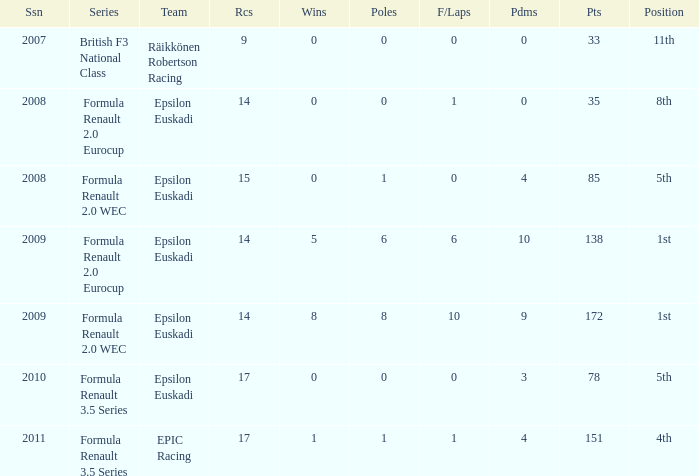What team was he on when he had 10 f/laps? Epsilon Euskadi. 